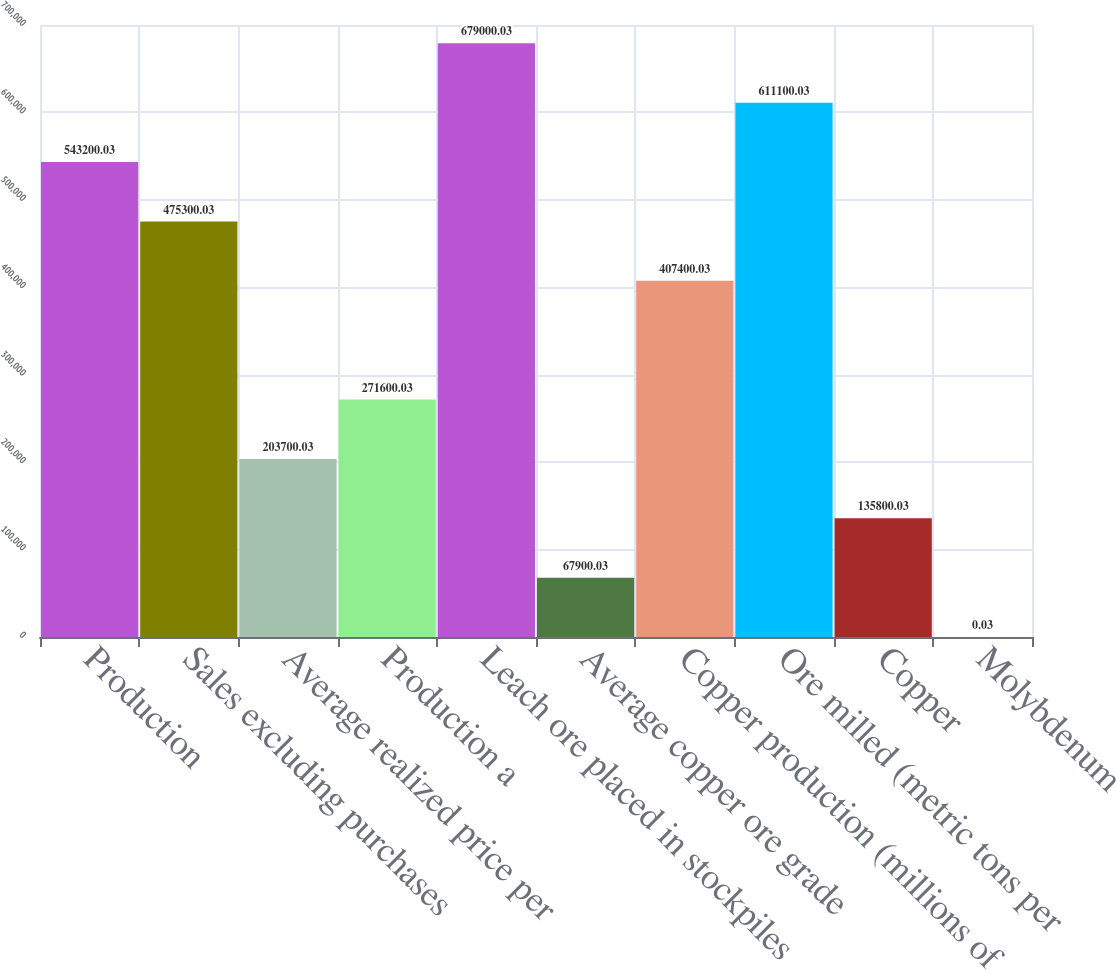Convert chart to OTSL. <chart><loc_0><loc_0><loc_500><loc_500><bar_chart><fcel>Production<fcel>Sales excluding purchases<fcel>Average realized price per<fcel>Production a<fcel>Leach ore placed in stockpiles<fcel>Average copper ore grade<fcel>Copper production (millions of<fcel>Ore milled (metric tons per<fcel>Copper<fcel>Molybdenum<nl><fcel>543200<fcel>475300<fcel>203700<fcel>271600<fcel>679000<fcel>67900<fcel>407400<fcel>611100<fcel>135800<fcel>0.03<nl></chart> 